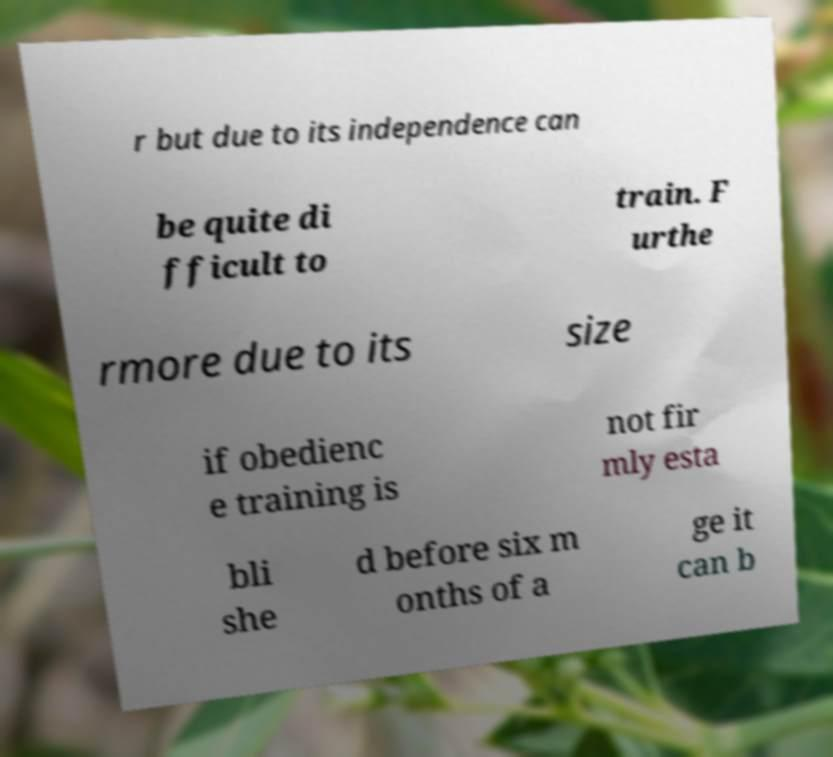Please identify and transcribe the text found in this image. r but due to its independence can be quite di fficult to train. F urthe rmore due to its size if obedienc e training is not fir mly esta bli she d before six m onths of a ge it can b 